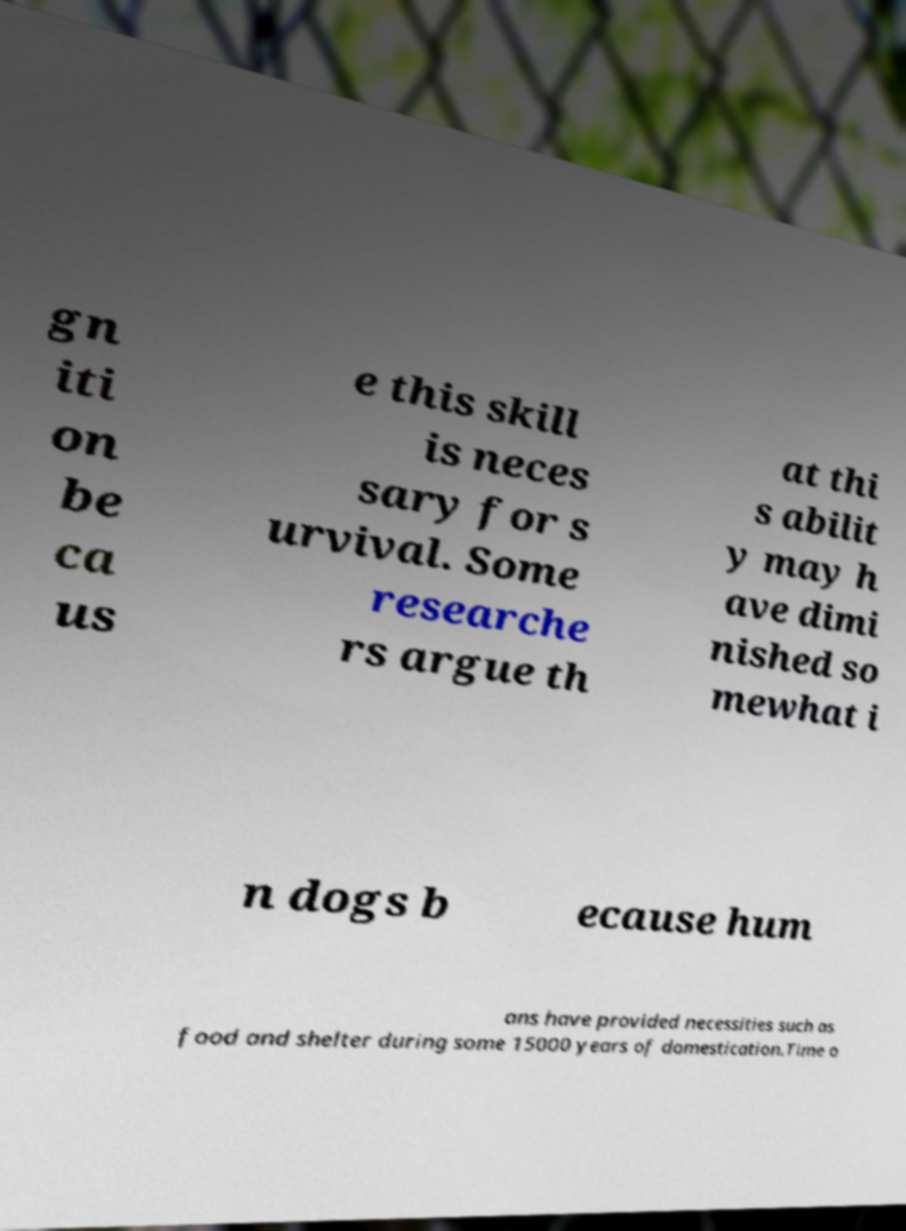There's text embedded in this image that I need extracted. Can you transcribe it verbatim? gn iti on be ca us e this skill is neces sary for s urvival. Some researche rs argue th at thi s abilit y may h ave dimi nished so mewhat i n dogs b ecause hum ans have provided necessities such as food and shelter during some 15000 years of domestication.Time o 